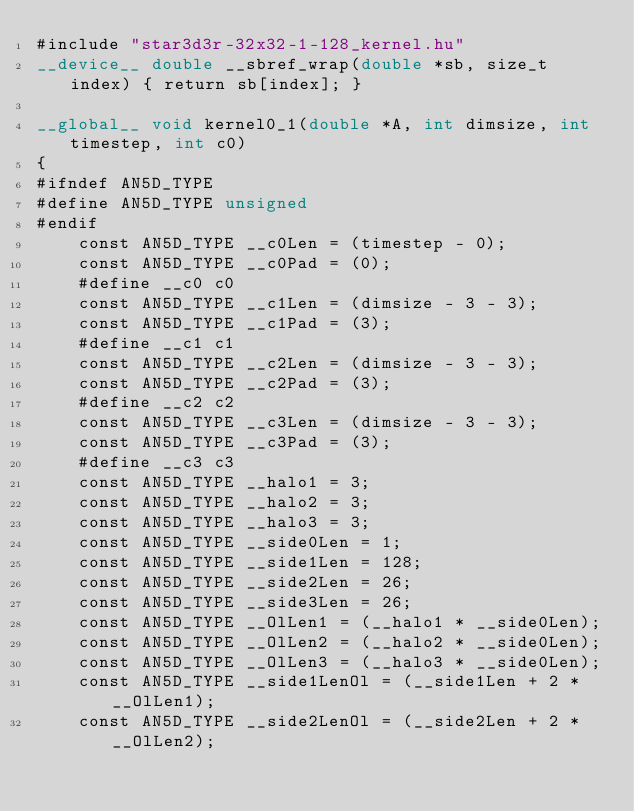<code> <loc_0><loc_0><loc_500><loc_500><_Cuda_>#include "star3d3r-32x32-1-128_kernel.hu"
__device__ double __sbref_wrap(double *sb, size_t index) { return sb[index]; }

__global__ void kernel0_1(double *A, int dimsize, int timestep, int c0)
{
#ifndef AN5D_TYPE
#define AN5D_TYPE unsigned
#endif
    const AN5D_TYPE __c0Len = (timestep - 0);
    const AN5D_TYPE __c0Pad = (0);
    #define __c0 c0
    const AN5D_TYPE __c1Len = (dimsize - 3 - 3);
    const AN5D_TYPE __c1Pad = (3);
    #define __c1 c1
    const AN5D_TYPE __c2Len = (dimsize - 3 - 3);
    const AN5D_TYPE __c2Pad = (3);
    #define __c2 c2
    const AN5D_TYPE __c3Len = (dimsize - 3 - 3);
    const AN5D_TYPE __c3Pad = (3);
    #define __c3 c3
    const AN5D_TYPE __halo1 = 3;
    const AN5D_TYPE __halo2 = 3;
    const AN5D_TYPE __halo3 = 3;
    const AN5D_TYPE __side0Len = 1;
    const AN5D_TYPE __side1Len = 128;
    const AN5D_TYPE __side2Len = 26;
    const AN5D_TYPE __side3Len = 26;
    const AN5D_TYPE __OlLen1 = (__halo1 * __side0Len);
    const AN5D_TYPE __OlLen2 = (__halo2 * __side0Len);
    const AN5D_TYPE __OlLen3 = (__halo3 * __side0Len);
    const AN5D_TYPE __side1LenOl = (__side1Len + 2 * __OlLen1);
    const AN5D_TYPE __side2LenOl = (__side2Len + 2 * __OlLen2);</code> 